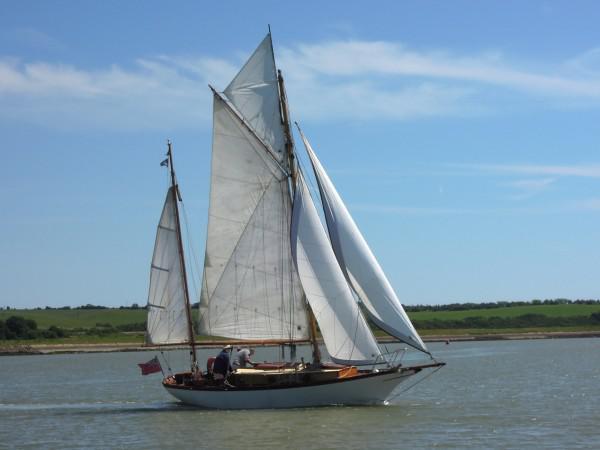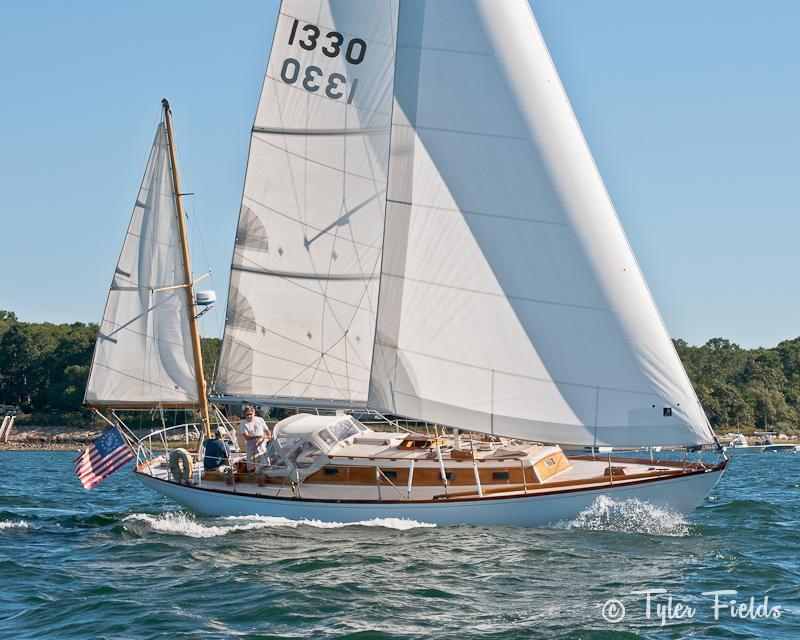The first image is the image on the left, the second image is the image on the right. Given the left and right images, does the statement "There are exactly four visible sails in the image on the left." hold true? Answer yes or no. Yes. 